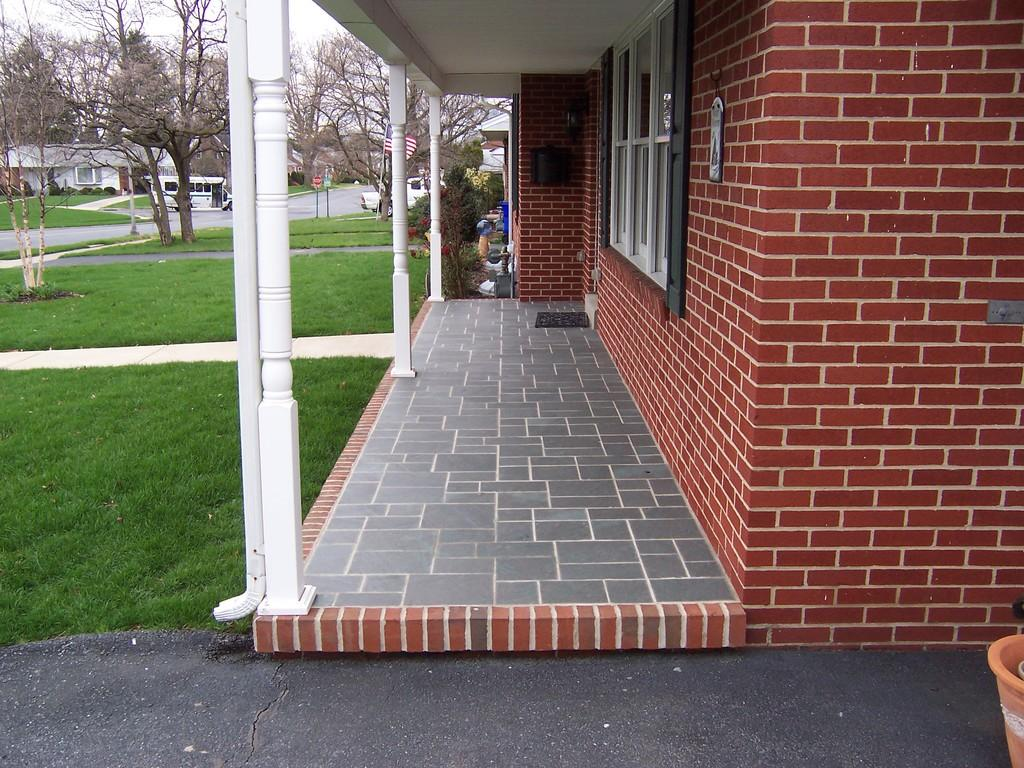What type of structure is visible in the image? There is a building with windows in the image. What is located in front of the building? There is a grass field in front of grass field in front of the building. Are there any other natural elements in the image? Yes, there are trees in the image. Can you describe the surrounding area in the image? There are other buildings visible in the image. How many masks can be seen hanging from the trees in the image? There are no masks present in the image; it features a building, grass field, trees, and other buildings. 